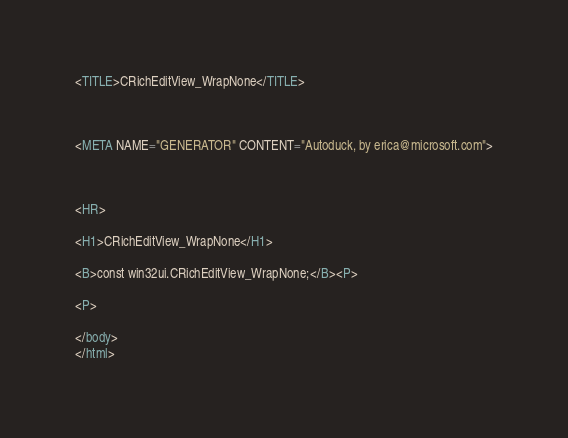<code> <loc_0><loc_0><loc_500><loc_500><_HTML_>


<TITLE>CRichEditView_WrapNone</TITLE>



<META NAME="GENERATOR" CONTENT="Autoduck, by erica@microsoft.com">



<HR>

<H1>CRichEditView_WrapNone</H1>

<B>const win32ui.CRichEditView_WrapNone;</B><P>

<P>

</body>
</html></code> 